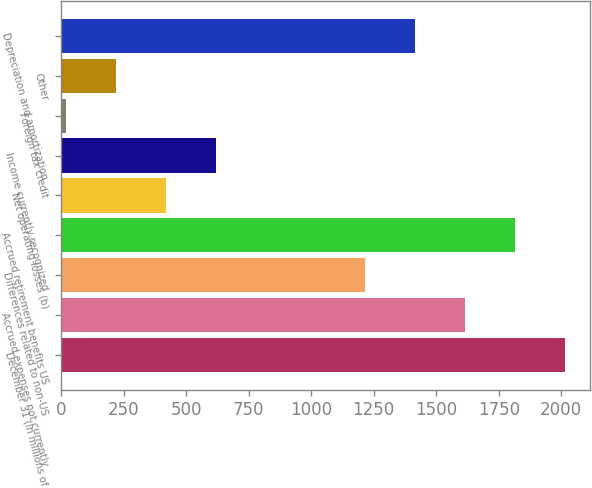<chart> <loc_0><loc_0><loc_500><loc_500><bar_chart><fcel>December 31 (In millions of<fcel>Accrued expenses not currently<fcel>Differences related to non-US<fcel>Accrued retirement benefits US<fcel>Net operating losses (b)<fcel>Income currently recognized<fcel>Foreign tax credit<fcel>Other<fcel>Depreciation and amortization<nl><fcel>2015<fcel>1616<fcel>1217<fcel>1815.5<fcel>419<fcel>618.5<fcel>20<fcel>219.5<fcel>1416.5<nl></chart> 